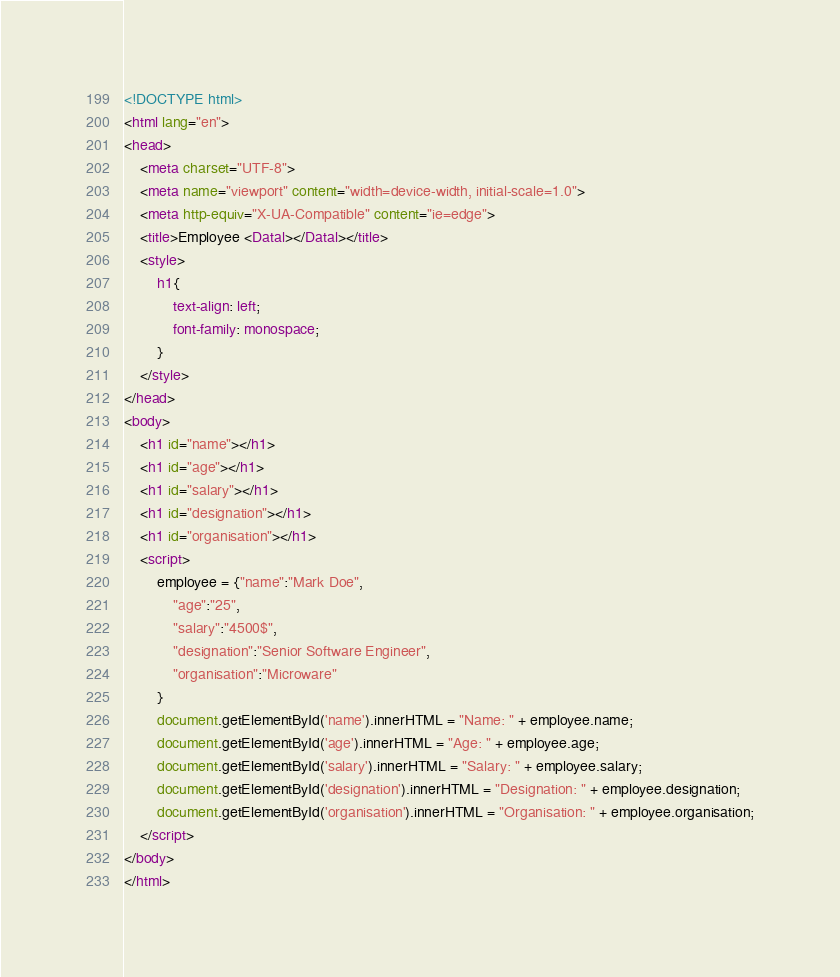Convert code to text. <code><loc_0><loc_0><loc_500><loc_500><_HTML_><!DOCTYPE html>
<html lang="en">
<head>
    <meta charset="UTF-8">
    <meta name="viewport" content="width=device-width, initial-scale=1.0">
    <meta http-equiv="X-UA-Compatible" content="ie=edge">
    <title>Employee <Datal></Datal></title>
    <style>
        h1{
            text-align: left;
            font-family: monospace;
        }
    </style>
</head>
<body>
    <h1 id="name"></h1>
    <h1 id="age"></h1>
    <h1 id="salary"></h1>
    <h1 id="designation"></h1>
    <h1 id="organisation"></h1>
    <script>
        employee = {"name":"Mark Doe",
            "age":"25",
            "salary":"4500$",
            "designation":"Senior Software Engineer",
            "organisation":"Microware"
        }
        document.getElementById('name').innerHTML = "Name: " + employee.name;
        document.getElementById('age').innerHTML = "Age: " + employee.age;
        document.getElementById('salary').innerHTML = "Salary: " + employee.salary;
        document.getElementById('designation').innerHTML = "Designation: " + employee.designation;
        document.getElementById('organisation').innerHTML = "Organisation: " + employee.organisation;
    </script>
</body>
</html></code> 